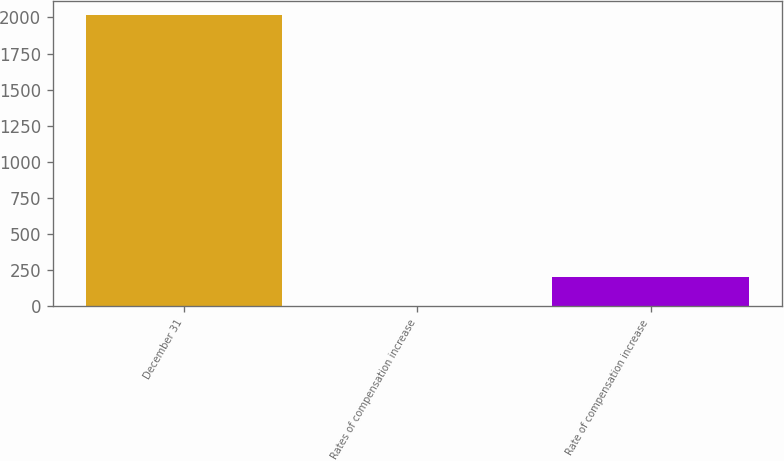Convert chart to OTSL. <chart><loc_0><loc_0><loc_500><loc_500><bar_chart><fcel>December 31<fcel>Rates of compensation increase<fcel>Rate of compensation increase<nl><fcel>2014<fcel>1<fcel>202.3<nl></chart> 